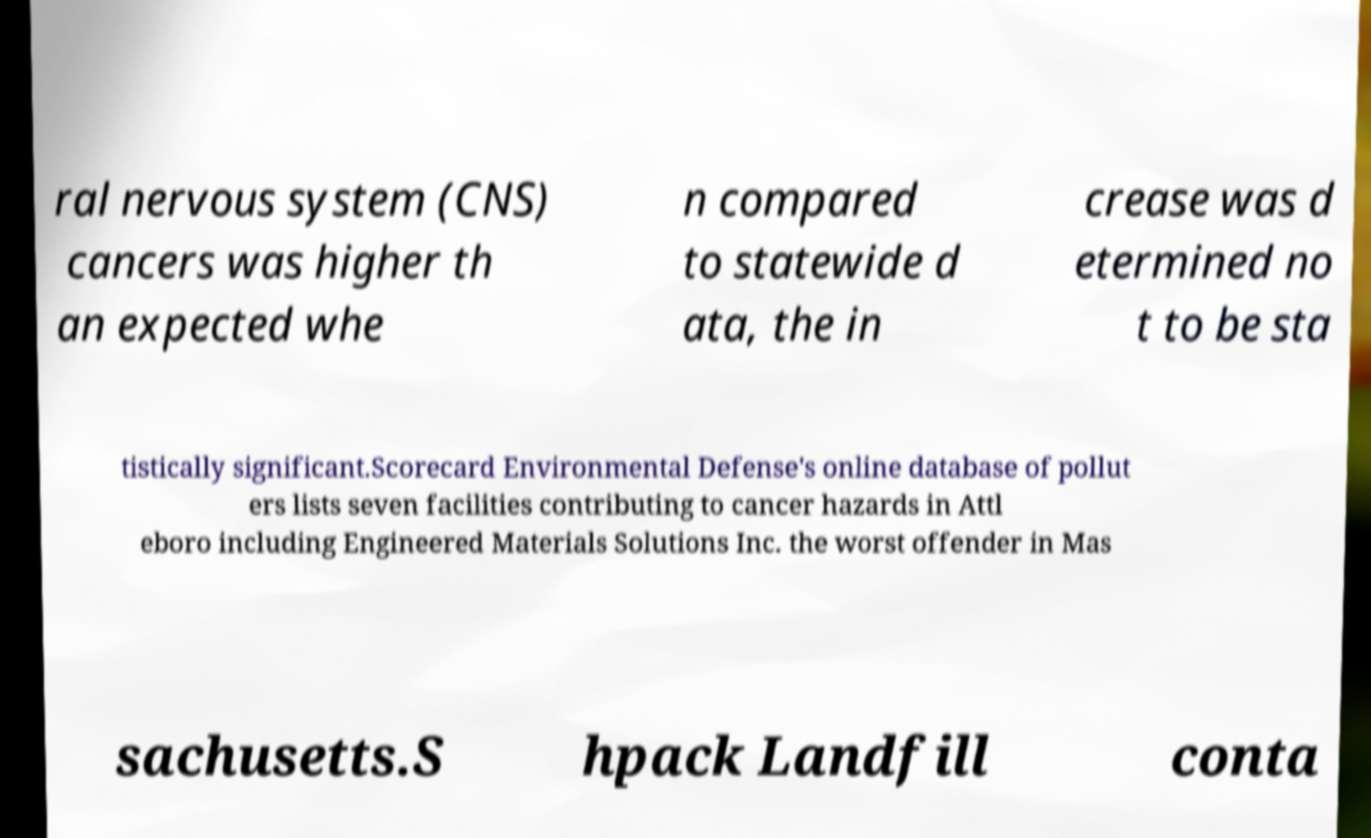Can you read and provide the text displayed in the image?This photo seems to have some interesting text. Can you extract and type it out for me? ral nervous system (CNS) cancers was higher th an expected whe n compared to statewide d ata, the in crease was d etermined no t to be sta tistically significant.Scorecard Environmental Defense's online database of pollut ers lists seven facilities contributing to cancer hazards in Attl eboro including Engineered Materials Solutions Inc. the worst offender in Mas sachusetts.S hpack Landfill conta 